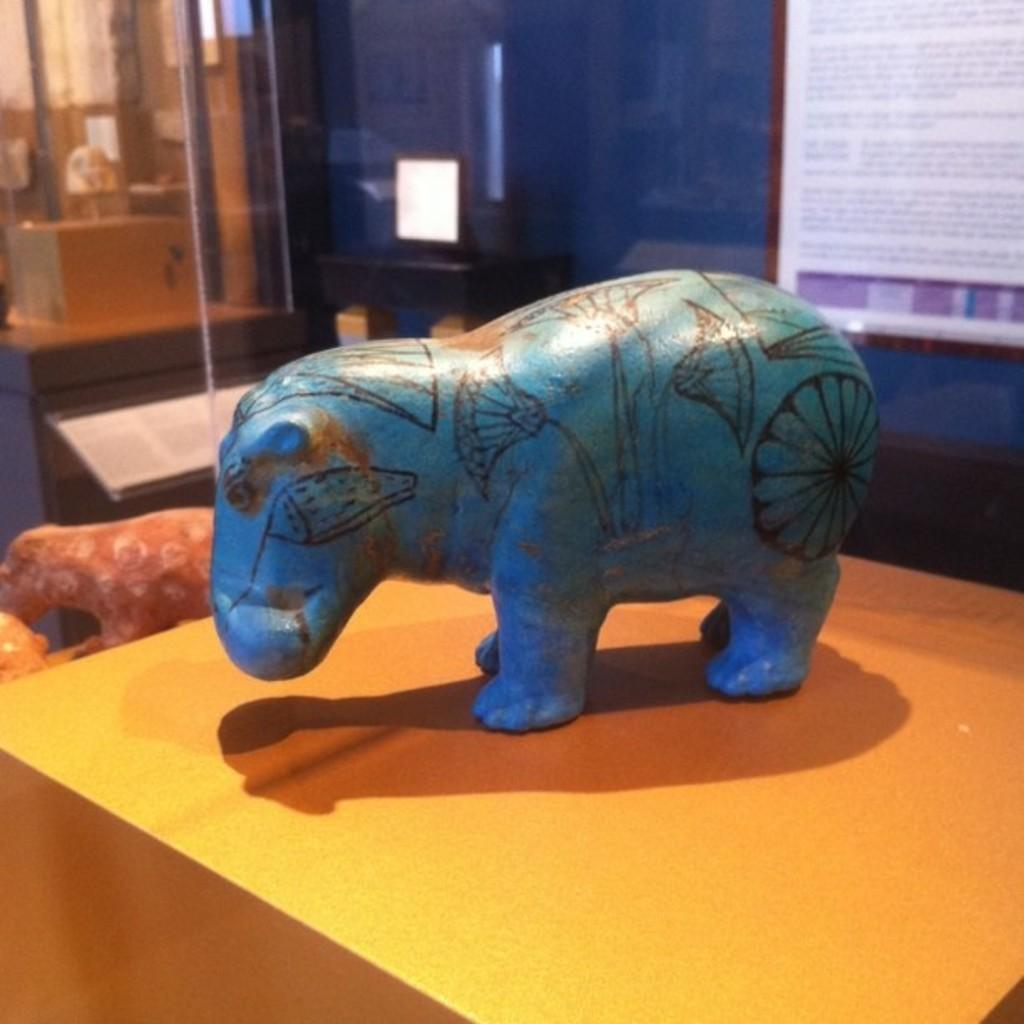What object can be seen on the table in the image? There is a toy on the table in the image. What is hanging on the wall in the image? There is a poster on the wall in the image. What electronic device is present in the image? There is a monitor in the image. Are there any other toys visible in the image? Yes, there are additional toys on the side in the image. Can you see any pigs swimming in the ocean in the image? There is no ocean or pigs present in the image. 